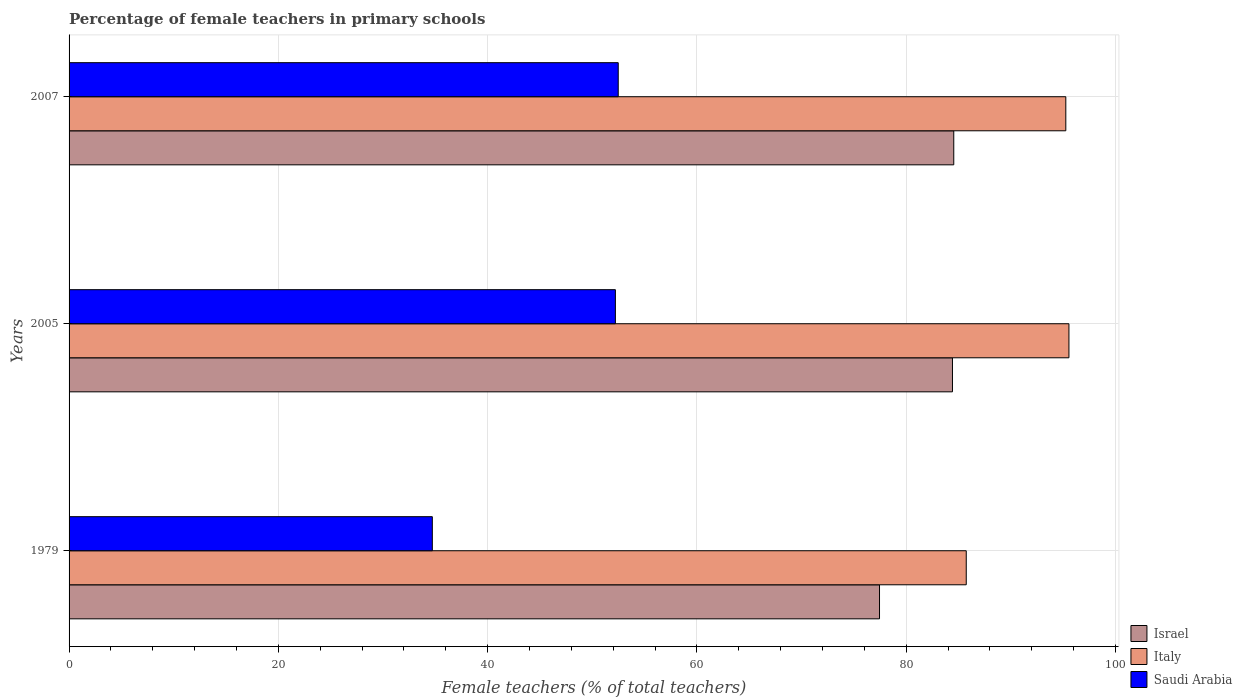How many groups of bars are there?
Make the answer very short. 3. What is the label of the 1st group of bars from the top?
Make the answer very short. 2007. In how many cases, is the number of bars for a given year not equal to the number of legend labels?
Make the answer very short. 0. What is the percentage of female teachers in Israel in 2007?
Provide a succinct answer. 84.55. Across all years, what is the maximum percentage of female teachers in Israel?
Offer a very short reply. 84.55. Across all years, what is the minimum percentage of female teachers in Italy?
Offer a very short reply. 85.74. In which year was the percentage of female teachers in Israel maximum?
Offer a very short reply. 2007. In which year was the percentage of female teachers in Italy minimum?
Keep it short and to the point. 1979. What is the total percentage of female teachers in Saudi Arabia in the graph?
Your answer should be compact. 139.4. What is the difference between the percentage of female teachers in Israel in 1979 and that in 2005?
Ensure brevity in your answer.  -6.97. What is the difference between the percentage of female teachers in Israel in 1979 and the percentage of female teachers in Saudi Arabia in 2005?
Make the answer very short. 25.24. What is the average percentage of female teachers in Saudi Arabia per year?
Give a very brief answer. 46.47. In the year 2005, what is the difference between the percentage of female teachers in Israel and percentage of female teachers in Saudi Arabia?
Your response must be concise. 32.21. In how many years, is the percentage of female teachers in Italy greater than 56 %?
Your answer should be compact. 3. What is the ratio of the percentage of female teachers in Saudi Arabia in 1979 to that in 2005?
Give a very brief answer. 0.66. Is the difference between the percentage of female teachers in Israel in 2005 and 2007 greater than the difference between the percentage of female teachers in Saudi Arabia in 2005 and 2007?
Offer a terse response. Yes. What is the difference between the highest and the second highest percentage of female teachers in Israel?
Your answer should be compact. 0.12. What is the difference between the highest and the lowest percentage of female teachers in Saudi Arabia?
Offer a terse response. 17.77. What does the 1st bar from the top in 1979 represents?
Keep it short and to the point. Saudi Arabia. What does the 1st bar from the bottom in 2005 represents?
Make the answer very short. Israel. Is it the case that in every year, the sum of the percentage of female teachers in Israel and percentage of female teachers in Italy is greater than the percentage of female teachers in Saudi Arabia?
Your answer should be compact. Yes. Are all the bars in the graph horizontal?
Your answer should be compact. Yes. What is the difference between two consecutive major ticks on the X-axis?
Provide a succinct answer. 20. Does the graph contain any zero values?
Keep it short and to the point. No. Where does the legend appear in the graph?
Ensure brevity in your answer.  Bottom right. What is the title of the graph?
Give a very brief answer. Percentage of female teachers in primary schools. Does "Rwanda" appear as one of the legend labels in the graph?
Provide a succinct answer. No. What is the label or title of the X-axis?
Your answer should be very brief. Female teachers (% of total teachers). What is the label or title of the Y-axis?
Provide a succinct answer. Years. What is the Female teachers (% of total teachers) of Israel in 1979?
Offer a very short reply. 77.45. What is the Female teachers (% of total teachers) of Italy in 1979?
Give a very brief answer. 85.74. What is the Female teachers (% of total teachers) of Saudi Arabia in 1979?
Your answer should be very brief. 34.71. What is the Female teachers (% of total teachers) in Israel in 2005?
Ensure brevity in your answer.  84.42. What is the Female teachers (% of total teachers) in Italy in 2005?
Your answer should be very brief. 95.55. What is the Female teachers (% of total teachers) of Saudi Arabia in 2005?
Provide a short and direct response. 52.21. What is the Female teachers (% of total teachers) in Israel in 2007?
Provide a succinct answer. 84.55. What is the Female teachers (% of total teachers) of Italy in 2007?
Your answer should be compact. 95.25. What is the Female teachers (% of total teachers) of Saudi Arabia in 2007?
Give a very brief answer. 52.48. Across all years, what is the maximum Female teachers (% of total teachers) in Israel?
Offer a terse response. 84.55. Across all years, what is the maximum Female teachers (% of total teachers) of Italy?
Your answer should be compact. 95.55. Across all years, what is the maximum Female teachers (% of total teachers) in Saudi Arabia?
Offer a very short reply. 52.48. Across all years, what is the minimum Female teachers (% of total teachers) in Israel?
Provide a short and direct response. 77.45. Across all years, what is the minimum Female teachers (% of total teachers) of Italy?
Your answer should be compact. 85.74. Across all years, what is the minimum Female teachers (% of total teachers) in Saudi Arabia?
Ensure brevity in your answer.  34.71. What is the total Female teachers (% of total teachers) in Israel in the graph?
Provide a succinct answer. 246.42. What is the total Female teachers (% of total teachers) of Italy in the graph?
Offer a terse response. 276.54. What is the total Female teachers (% of total teachers) in Saudi Arabia in the graph?
Provide a short and direct response. 139.4. What is the difference between the Female teachers (% of total teachers) in Israel in 1979 and that in 2005?
Offer a very short reply. -6.97. What is the difference between the Female teachers (% of total teachers) in Italy in 1979 and that in 2005?
Offer a terse response. -9.81. What is the difference between the Female teachers (% of total teachers) in Saudi Arabia in 1979 and that in 2005?
Give a very brief answer. -17.49. What is the difference between the Female teachers (% of total teachers) of Israel in 1979 and that in 2007?
Keep it short and to the point. -7.1. What is the difference between the Female teachers (% of total teachers) of Italy in 1979 and that in 2007?
Offer a terse response. -9.51. What is the difference between the Female teachers (% of total teachers) in Saudi Arabia in 1979 and that in 2007?
Offer a terse response. -17.77. What is the difference between the Female teachers (% of total teachers) in Israel in 2005 and that in 2007?
Your answer should be compact. -0.12. What is the difference between the Female teachers (% of total teachers) of Italy in 2005 and that in 2007?
Give a very brief answer. 0.3. What is the difference between the Female teachers (% of total teachers) in Saudi Arabia in 2005 and that in 2007?
Keep it short and to the point. -0.27. What is the difference between the Female teachers (% of total teachers) in Israel in 1979 and the Female teachers (% of total teachers) in Italy in 2005?
Your response must be concise. -18.1. What is the difference between the Female teachers (% of total teachers) of Israel in 1979 and the Female teachers (% of total teachers) of Saudi Arabia in 2005?
Make the answer very short. 25.24. What is the difference between the Female teachers (% of total teachers) in Italy in 1979 and the Female teachers (% of total teachers) in Saudi Arabia in 2005?
Your answer should be very brief. 33.53. What is the difference between the Female teachers (% of total teachers) of Israel in 1979 and the Female teachers (% of total teachers) of Italy in 2007?
Make the answer very short. -17.8. What is the difference between the Female teachers (% of total teachers) of Israel in 1979 and the Female teachers (% of total teachers) of Saudi Arabia in 2007?
Make the answer very short. 24.97. What is the difference between the Female teachers (% of total teachers) of Italy in 1979 and the Female teachers (% of total teachers) of Saudi Arabia in 2007?
Offer a terse response. 33.26. What is the difference between the Female teachers (% of total teachers) in Israel in 2005 and the Female teachers (% of total teachers) in Italy in 2007?
Your answer should be very brief. -10.83. What is the difference between the Female teachers (% of total teachers) of Israel in 2005 and the Female teachers (% of total teachers) of Saudi Arabia in 2007?
Give a very brief answer. 31.94. What is the difference between the Female teachers (% of total teachers) of Italy in 2005 and the Female teachers (% of total teachers) of Saudi Arabia in 2007?
Make the answer very short. 43.07. What is the average Female teachers (% of total teachers) of Israel per year?
Your response must be concise. 82.14. What is the average Female teachers (% of total teachers) of Italy per year?
Offer a very short reply. 92.18. What is the average Female teachers (% of total teachers) of Saudi Arabia per year?
Ensure brevity in your answer.  46.47. In the year 1979, what is the difference between the Female teachers (% of total teachers) in Israel and Female teachers (% of total teachers) in Italy?
Your response must be concise. -8.29. In the year 1979, what is the difference between the Female teachers (% of total teachers) in Israel and Female teachers (% of total teachers) in Saudi Arabia?
Give a very brief answer. 42.74. In the year 1979, what is the difference between the Female teachers (% of total teachers) in Italy and Female teachers (% of total teachers) in Saudi Arabia?
Keep it short and to the point. 51.02. In the year 2005, what is the difference between the Female teachers (% of total teachers) of Israel and Female teachers (% of total teachers) of Italy?
Keep it short and to the point. -11.13. In the year 2005, what is the difference between the Female teachers (% of total teachers) in Israel and Female teachers (% of total teachers) in Saudi Arabia?
Make the answer very short. 32.21. In the year 2005, what is the difference between the Female teachers (% of total teachers) in Italy and Female teachers (% of total teachers) in Saudi Arabia?
Provide a succinct answer. 43.34. In the year 2007, what is the difference between the Female teachers (% of total teachers) in Israel and Female teachers (% of total teachers) in Italy?
Your answer should be compact. -10.71. In the year 2007, what is the difference between the Female teachers (% of total teachers) of Israel and Female teachers (% of total teachers) of Saudi Arabia?
Your answer should be compact. 32.06. In the year 2007, what is the difference between the Female teachers (% of total teachers) of Italy and Female teachers (% of total teachers) of Saudi Arabia?
Make the answer very short. 42.77. What is the ratio of the Female teachers (% of total teachers) in Israel in 1979 to that in 2005?
Your answer should be very brief. 0.92. What is the ratio of the Female teachers (% of total teachers) of Italy in 1979 to that in 2005?
Your answer should be very brief. 0.9. What is the ratio of the Female teachers (% of total teachers) in Saudi Arabia in 1979 to that in 2005?
Your answer should be very brief. 0.66. What is the ratio of the Female teachers (% of total teachers) of Israel in 1979 to that in 2007?
Offer a terse response. 0.92. What is the ratio of the Female teachers (% of total teachers) in Italy in 1979 to that in 2007?
Ensure brevity in your answer.  0.9. What is the ratio of the Female teachers (% of total teachers) of Saudi Arabia in 1979 to that in 2007?
Keep it short and to the point. 0.66. What is the ratio of the Female teachers (% of total teachers) in Italy in 2005 to that in 2007?
Provide a short and direct response. 1. What is the difference between the highest and the second highest Female teachers (% of total teachers) of Israel?
Your answer should be very brief. 0.12. What is the difference between the highest and the second highest Female teachers (% of total teachers) of Italy?
Make the answer very short. 0.3. What is the difference between the highest and the second highest Female teachers (% of total teachers) in Saudi Arabia?
Offer a terse response. 0.27. What is the difference between the highest and the lowest Female teachers (% of total teachers) of Israel?
Provide a short and direct response. 7.1. What is the difference between the highest and the lowest Female teachers (% of total teachers) in Italy?
Provide a succinct answer. 9.81. What is the difference between the highest and the lowest Female teachers (% of total teachers) in Saudi Arabia?
Your answer should be compact. 17.77. 